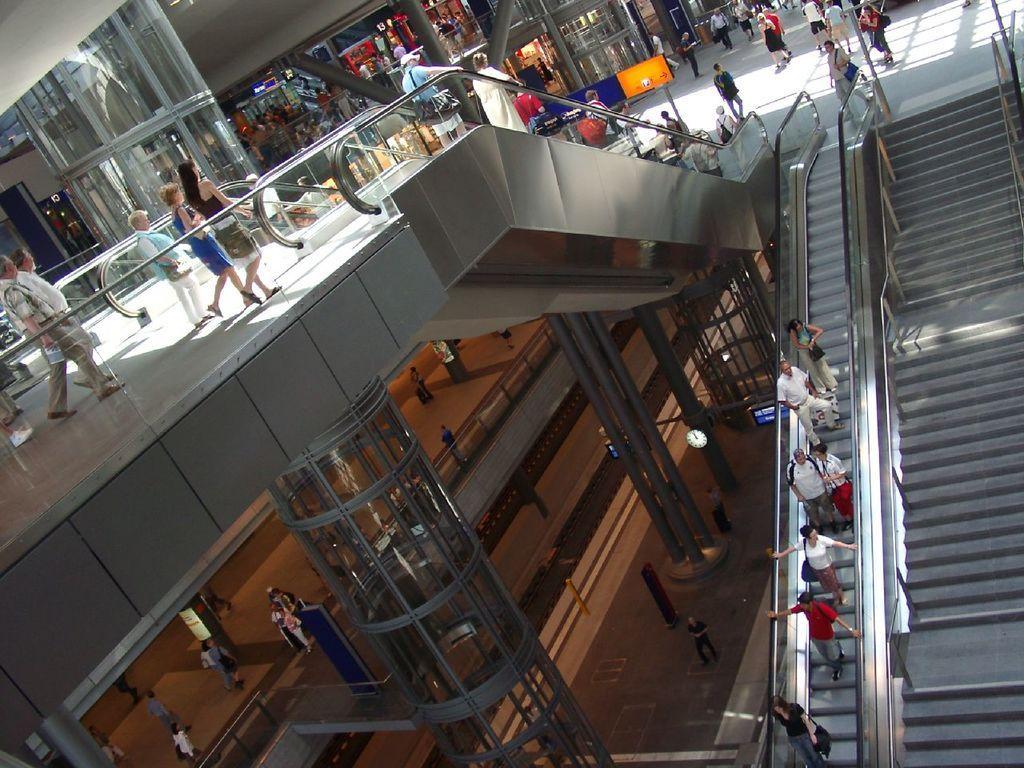Please provide a concise description of this image. In this picture I can see there is a shopping mall and there is a escalators and there are some people standing on the escalator and there are some stairs here and there are some shopping centers here. 